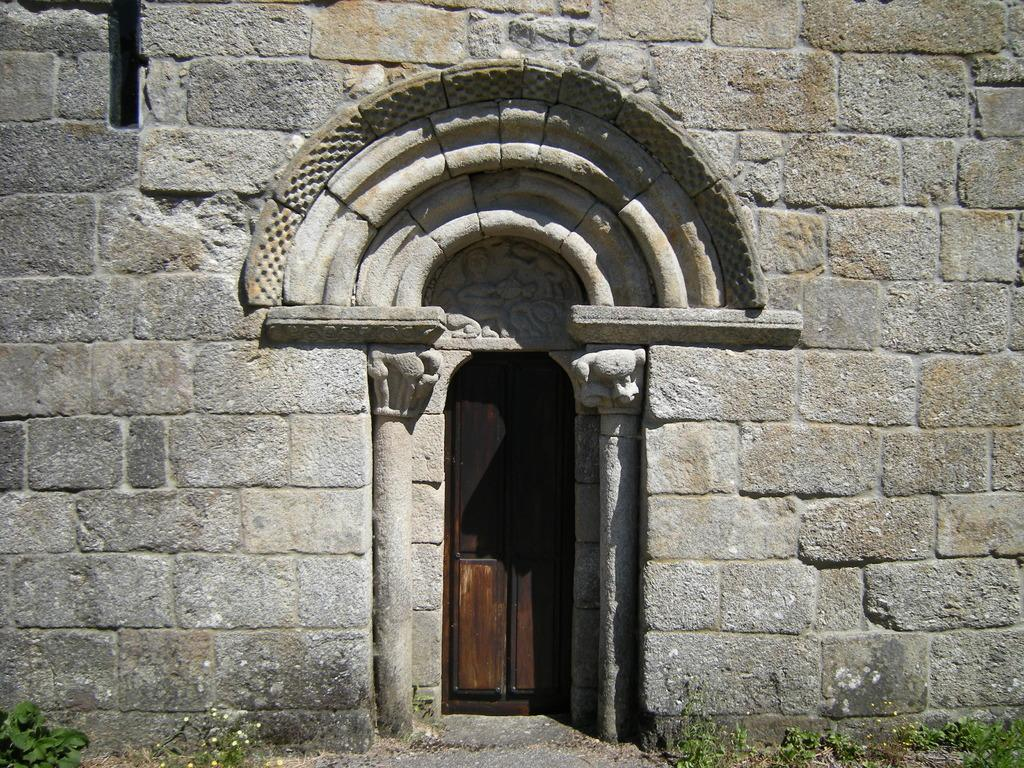What type of structure is depicted in the image? There is a castle in the image. What material is used for the walls of the castle? The castle has stone walls. Where is the entrance to the castle located? There is a door in the center of the castle. What type of vegetation is present at the bottom of the image? There are plants at the bottom of the image. What type of table is used for the holiday celebration in the image? There is no table or holiday celebration present in the image; it features a castle with stone walls and a door. 